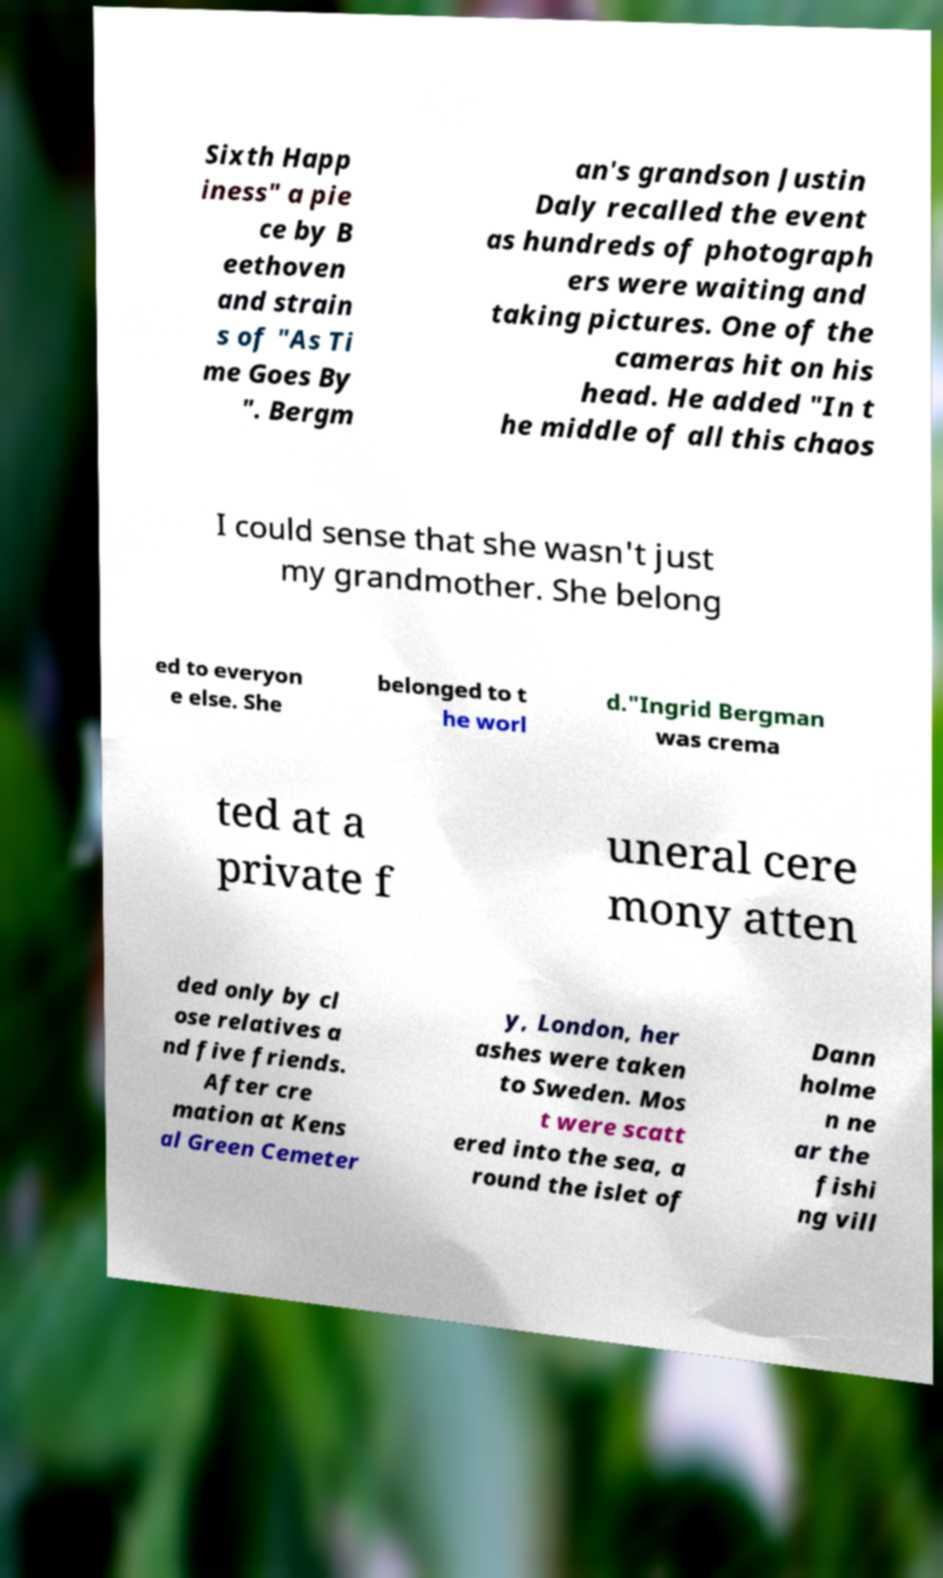Can you accurately transcribe the text from the provided image for me? Sixth Happ iness" a pie ce by B eethoven and strain s of "As Ti me Goes By ". Bergm an's grandson Justin Daly recalled the event as hundreds of photograph ers were waiting and taking pictures. One of the cameras hit on his head. He added "In t he middle of all this chaos I could sense that she wasn't just my grandmother. She belong ed to everyon e else. She belonged to t he worl d."Ingrid Bergman was crema ted at a private f uneral cere mony atten ded only by cl ose relatives a nd five friends. After cre mation at Kens al Green Cemeter y, London, her ashes were taken to Sweden. Mos t were scatt ered into the sea, a round the islet of Dann holme n ne ar the fishi ng vill 